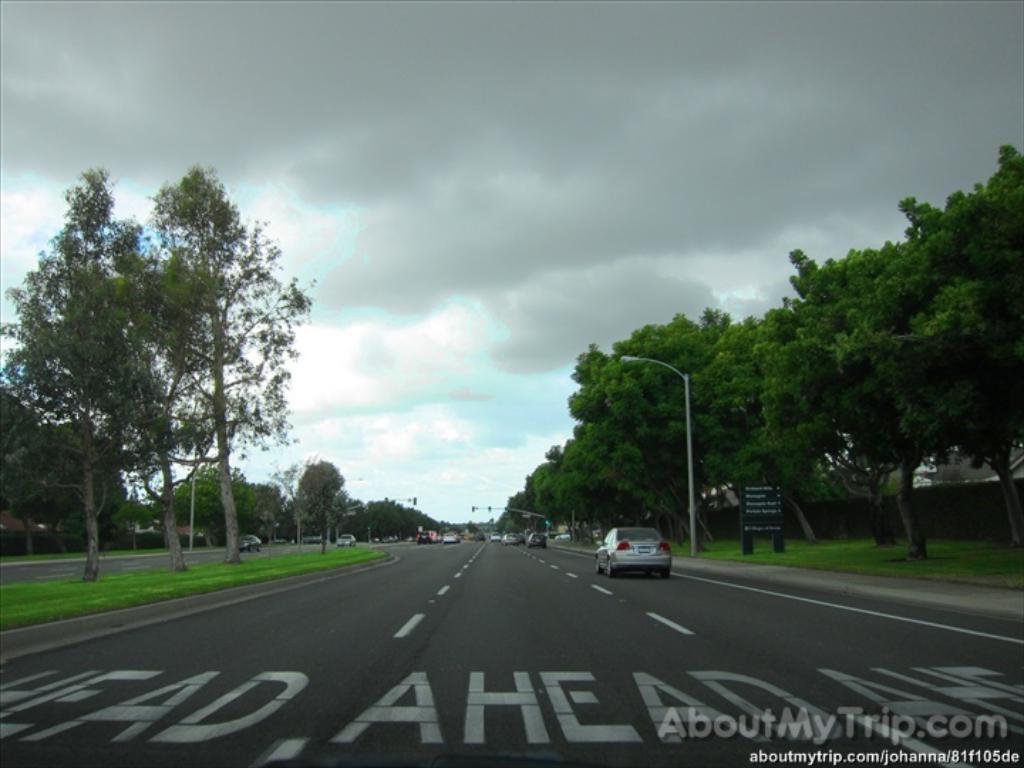Could you give a brief overview of what you see in this image? In the picture I can see vehicles on the road. I can also see trees, street lights, trees, grass, a board which has something written on it and some other objects. In the background I can see the sky. I can also see watermarks on the image. 